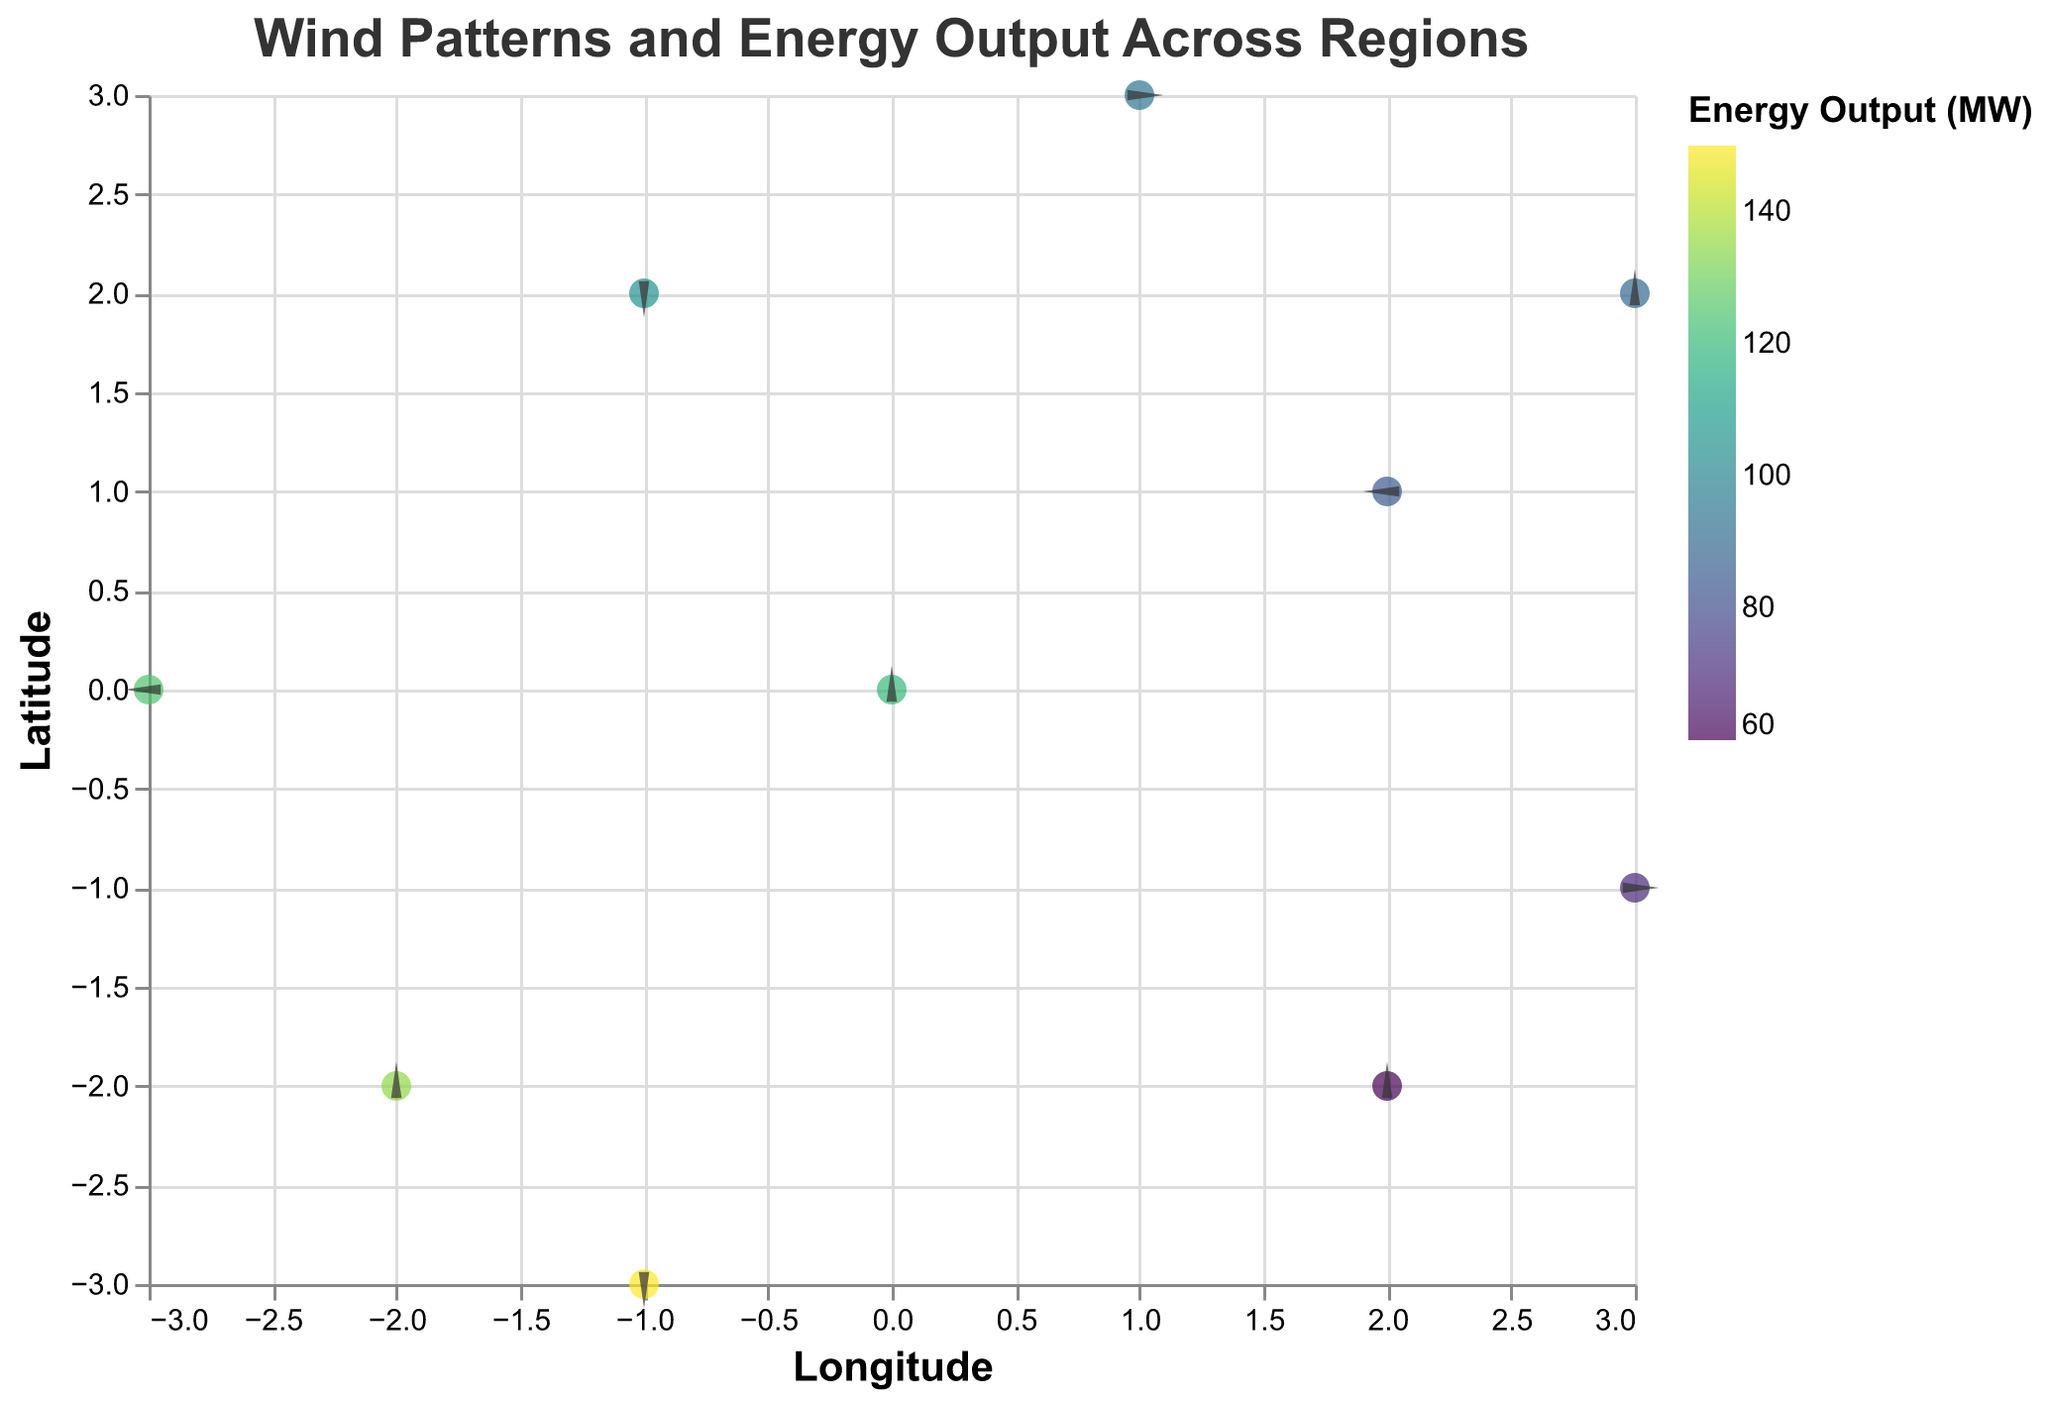What is the title of the plot? The title is typically at the top of the plot, labeled as "Wind Patterns and Energy Output Across Regions".
Answer: Wind Patterns and Energy Output Across Regions How many regions are displayed in the plot? Count the unique data points representing each region. There are 10 data points, each associated with a different region.
Answer: 10 Which region has the highest wind speed? Look at the tooltip information for wind speed across all regions. Cape of Good Hope has the highest wind speed of 10.5 m/s.
Answer: Cape of Good Hope Compare the energy outputs of the North Sea and Irish Sea. Which one is higher? Check the energy output values in the tooltip for both North Sea (120 MW) and Irish Sea (85 MW). North Sea has a higher energy output.
Answer: North Sea What are the coordinates of the region with the highest energy output? Identify the tooltip information for the highest energy output, which is 150 MW for Cape of Good Hope. The coordinates are (-1, -3).
Answer: (-1, -3) What is the average wind speed across all regions? Add the wind speeds from all regions (8.5 + 6.2 + 7.8 + 5.5 + 9.2 + 7.1 + 8.9 + 4.8 + 10.5 + 6.8 = 75.3) and divide by the number of regions (10). The average wind speed is 75.3/10 = 7.53 m/s.
Answer: 7.53 m/s Which two regions have the exact same directional component for the u vector? By inspecting the values for the u vector component, South China Sea and Tasman Sea both have u = 1.
Answer: South China Sea and Tasman Sea How does the energy output correlate with wind speed in the plot? Observe the general trend from high wind speed regions (Cape of Good Hope with 10.5 m/s and 150 MW) to lower wind speed regions (Persian Gulf with 4.8 m/s and 60 MW) reflecting a positive correlation.
Answer: Positively correlated What is the wind direction for the Bay of Bengal? For the Bay of Bengal, the u component is 2 and the v component is 0, indicating wind direction towards the right.
Answer: To the right Which region has the lowest energy output and what is its wind speed? Identify the lowest energy output (60 MW) in the Persian Gulf and check the wind speed, which is 4.8 m/s.
Answer: Persian Gulf, 4.8 m/s 